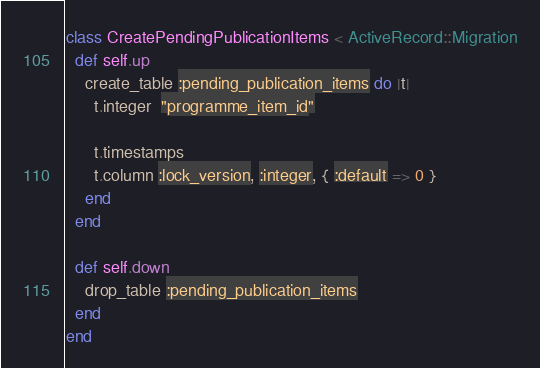<code> <loc_0><loc_0><loc_500><loc_500><_Ruby_>class CreatePendingPublicationItems < ActiveRecord::Migration
  def self.up
    create_table :pending_publication_items do |t|
      t.integer  "programme_item_id"

      t.timestamps
      t.column :lock_version, :integer, { :default => 0 }
    end
  end

  def self.down
    drop_table :pending_publication_items
  end
end
</code> 